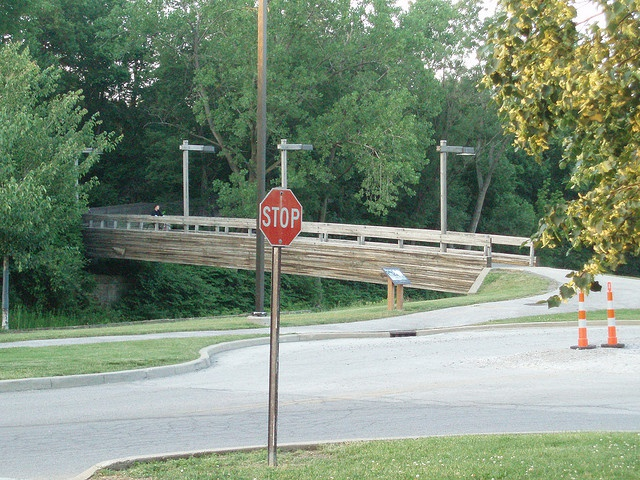Describe the objects in this image and their specific colors. I can see stop sign in teal, brown, and darkgray tones, people in teal, black, navy, and gray tones, and motorcycle in teal and gray tones in this image. 